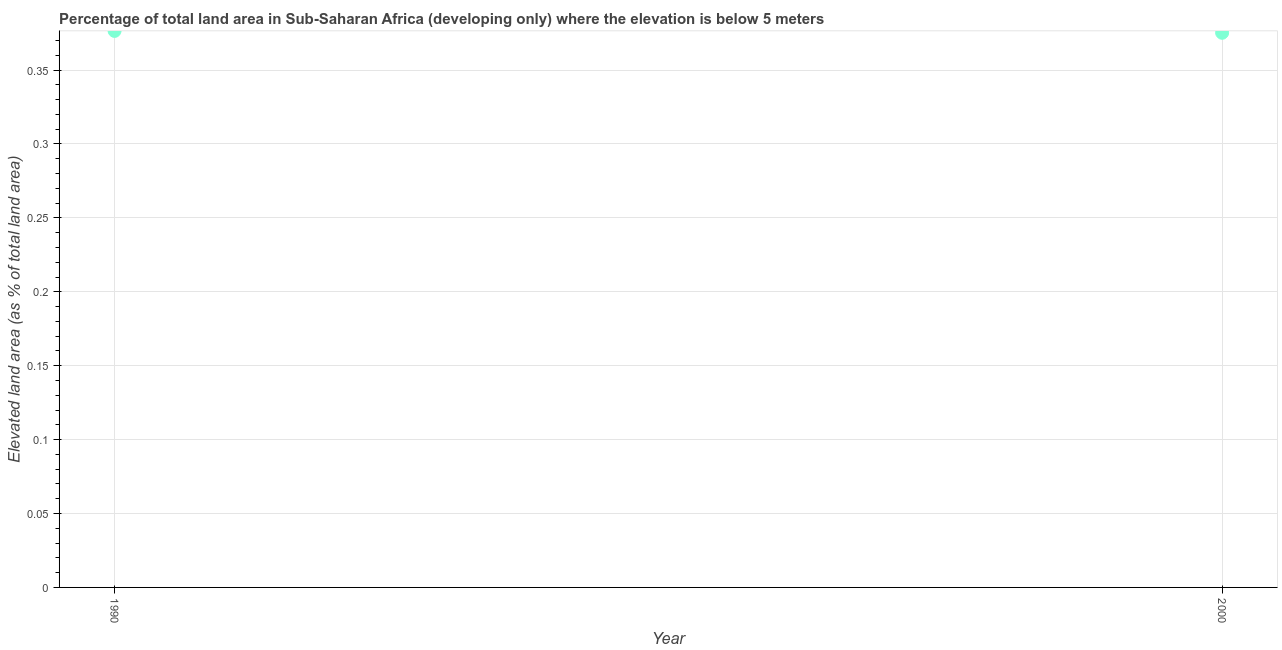What is the total elevated land area in 2000?
Your answer should be very brief. 0.38. Across all years, what is the maximum total elevated land area?
Make the answer very short. 0.38. Across all years, what is the minimum total elevated land area?
Offer a very short reply. 0.38. What is the sum of the total elevated land area?
Offer a very short reply. 0.75. What is the difference between the total elevated land area in 1990 and 2000?
Provide a short and direct response. 0. What is the average total elevated land area per year?
Your answer should be very brief. 0.38. What is the median total elevated land area?
Provide a short and direct response. 0.38. Do a majority of the years between 2000 and 1990 (inclusive) have total elevated land area greater than 0.03 %?
Provide a short and direct response. No. What is the ratio of the total elevated land area in 1990 to that in 2000?
Your response must be concise. 1. Is the total elevated land area in 1990 less than that in 2000?
Keep it short and to the point. No. What is the difference between two consecutive major ticks on the Y-axis?
Give a very brief answer. 0.05. Are the values on the major ticks of Y-axis written in scientific E-notation?
Keep it short and to the point. No. What is the title of the graph?
Provide a succinct answer. Percentage of total land area in Sub-Saharan Africa (developing only) where the elevation is below 5 meters. What is the label or title of the X-axis?
Provide a succinct answer. Year. What is the label or title of the Y-axis?
Your response must be concise. Elevated land area (as % of total land area). What is the Elevated land area (as % of total land area) in 1990?
Your answer should be compact. 0.38. What is the Elevated land area (as % of total land area) in 2000?
Offer a very short reply. 0.38. What is the difference between the Elevated land area (as % of total land area) in 1990 and 2000?
Make the answer very short. 0. What is the ratio of the Elevated land area (as % of total land area) in 1990 to that in 2000?
Your answer should be very brief. 1. 